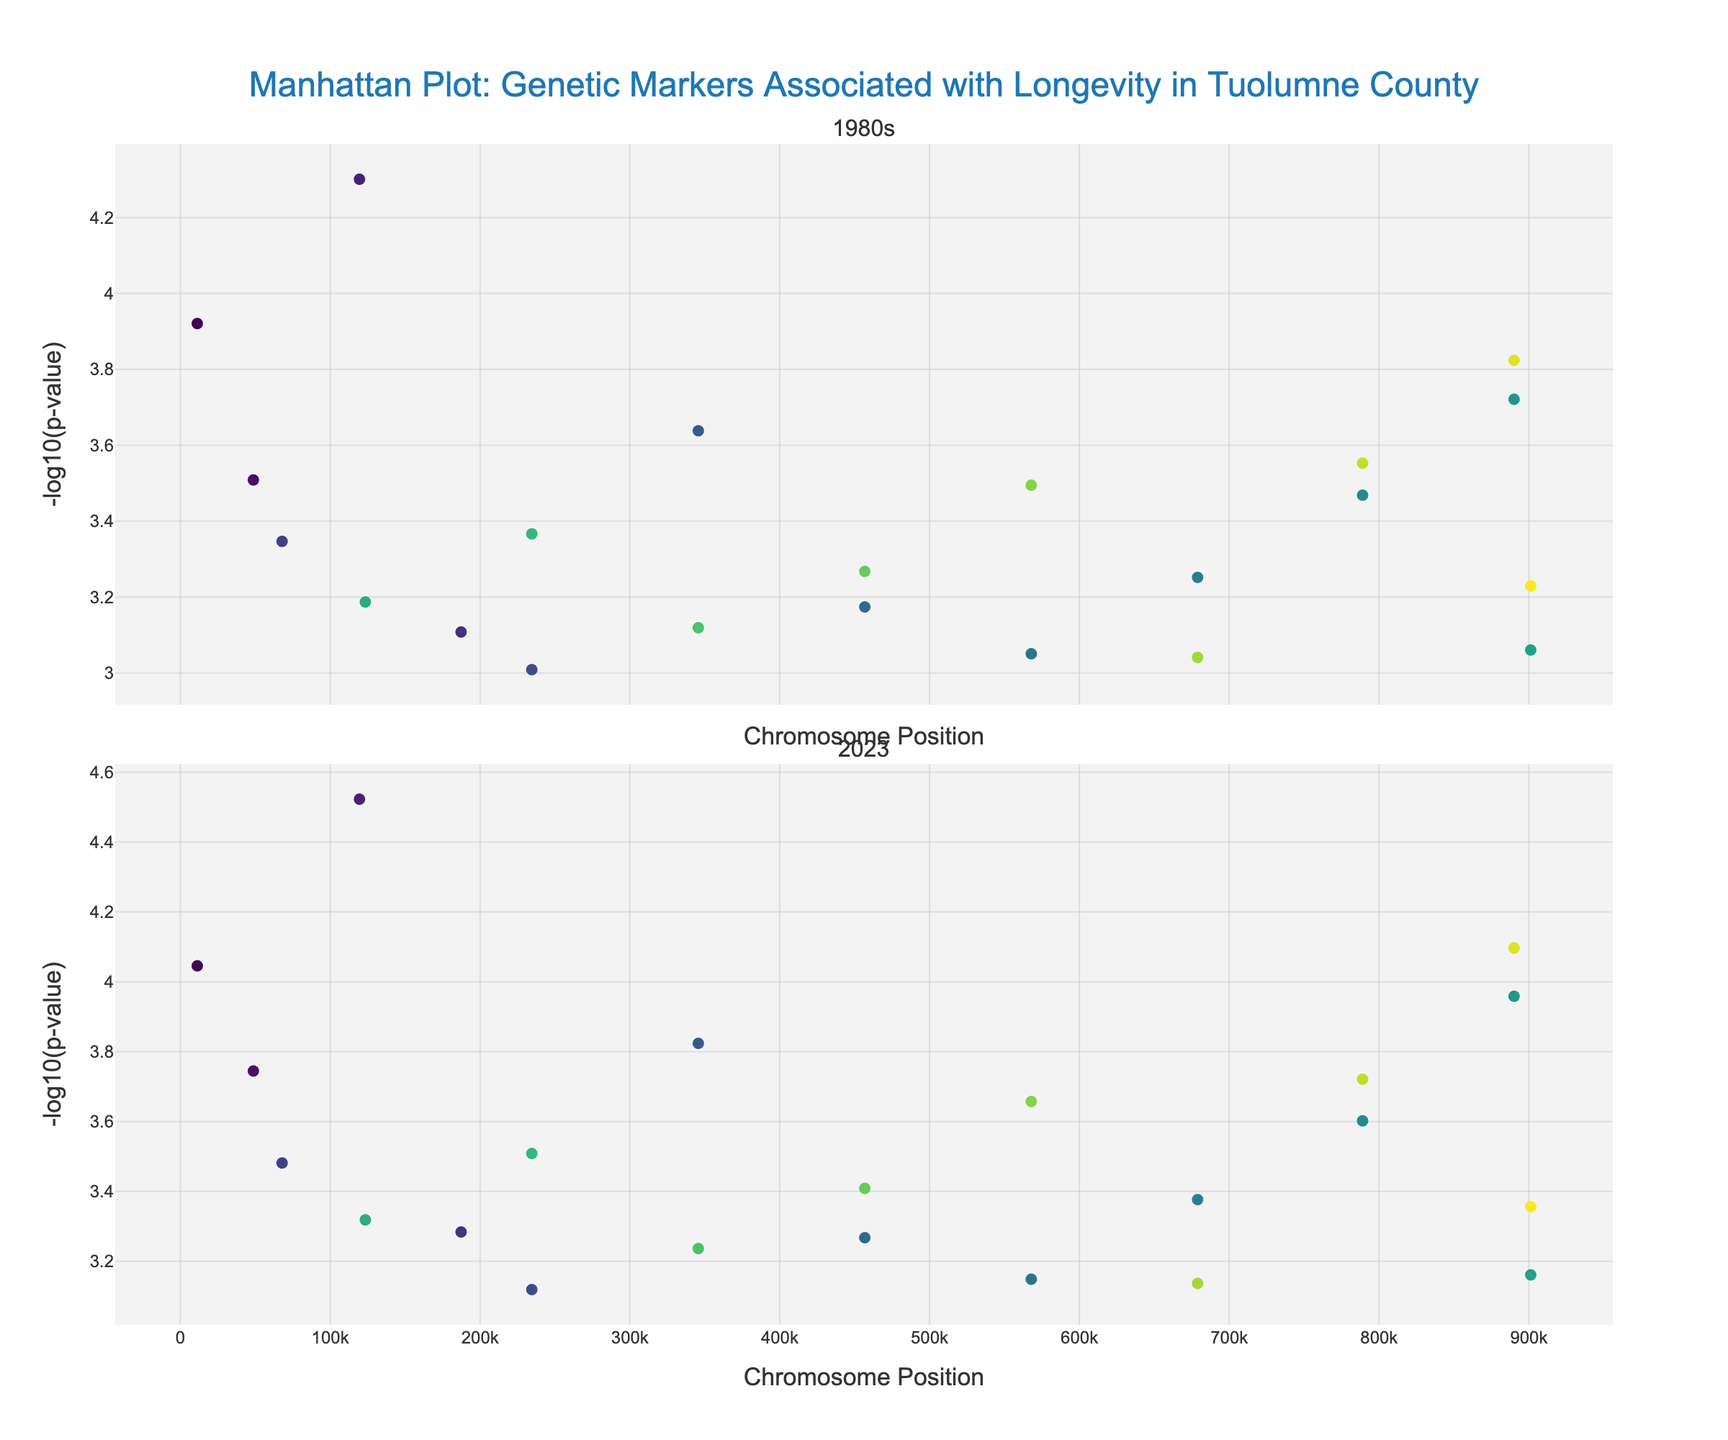How many genes are displayed on the 1980s Manhattan plot? To find the number of genes displayed on the 1980s Manhattan plot, you can count the number of markers (points) on the plot. Each point represents a gene along the chromosome positions.
Answer: 22 Which chromosome shows the highest -log10(p-value) in the 2023 plot? Look for the marker with the highest -log10(p-value) on the 2023 plot and identify its corresponding chromosome color. You can compare the colors to the Chromosome column.
Answer: Chromosome 3 What is the gene with the lowest p-value in the 1980s data? To determine the lowest p-value, find the highest -log10(p-value) on the 1980s plot, then refer to the corresponding gene text hover.
Answer: APOE By what factor did the p-value of TERT gene change from the 1980s to 2023? Calculate the factor change using the p-values from the TERT gene: P_value_1980s / P_value_2023 = 0.00015 / 0.00008.
Answer: 1.875 Which gene has shown the most significant decrease in p-value from the 1980s to 2023? To find the gene with the most significant decrease, calculate the difference in p-values for each gene and identify the one with the highest decrease.
Answer: APOE How does the -log10(p-value) of gene APOE compare between the 1980s and 2023? Compare the -log10(p-value) of the gene APOE between the two plots. The neg_log_p_1980s for APOE is -log10(0.00005), and the neg_log_p_2023 is -log10(0.00003).
Answer: 1980s: 4.30, 2023: 4.52 What pattern or trend can be observed in the -log10(p-values) across different chromosomes for 1980s vs. 2023? Compare the distribution and heights of the markers (representing -log10(p-values)) across both plots. Identify any patterns or trends between the two time periods.
Answer: P-values generally decreased over time Which gene on Chromosome 1 shows a more considerable significance decrease in 2023 compared to 1980s? Examine the difference in -log10(p-values) for genes on Chromosome 1, identifying which one shows a more significant decrease from 1980s to 2023.
Answer: MTHFR Are there any genes that did not show much change in p-value from 1980s to 2023? To identify such genes, compare the -log10(p-values) in the 1980s with those in 2023 and find genes with minimal differences.
Answer: APOC3 and TERT show relatively consistent values 